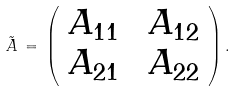<formula> <loc_0><loc_0><loc_500><loc_500>\tilde { A } \, = \, \left ( \begin{array} { c c } A _ { 1 1 } \, & \, A _ { 1 2 } \\ A _ { 2 1 } \, & \, A _ { 2 2 } \end{array} \right ) .</formula> 